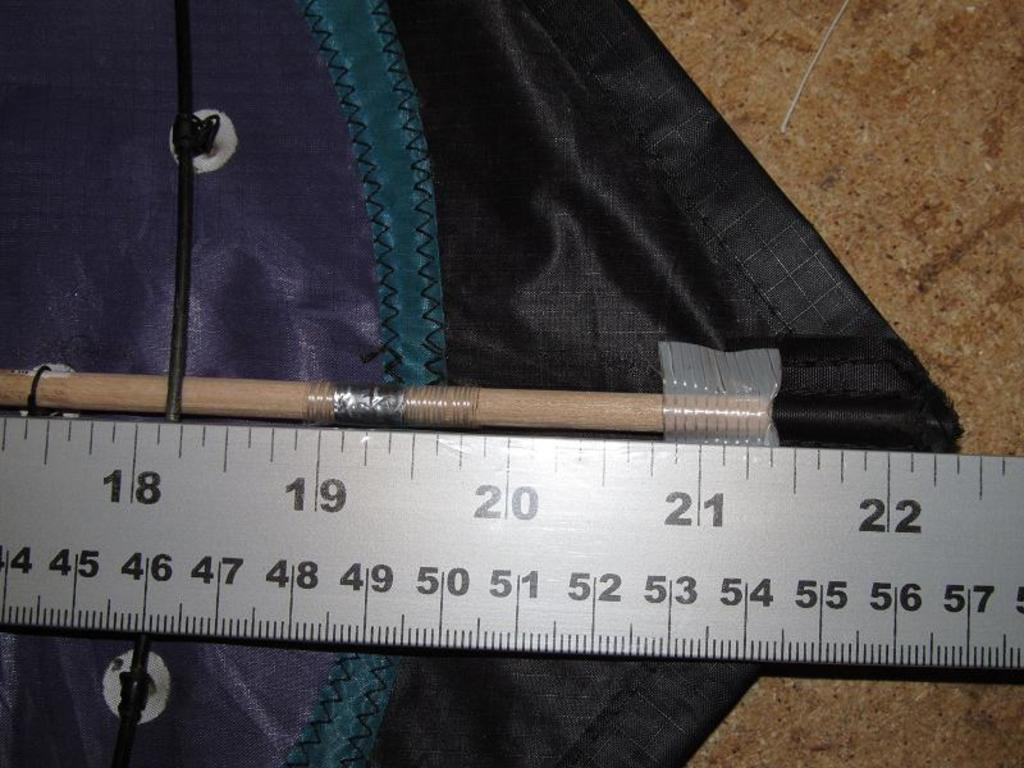<image>
Render a clear and concise summary of the photo. A ruler which has the numbers 18 to 22 along the top. 